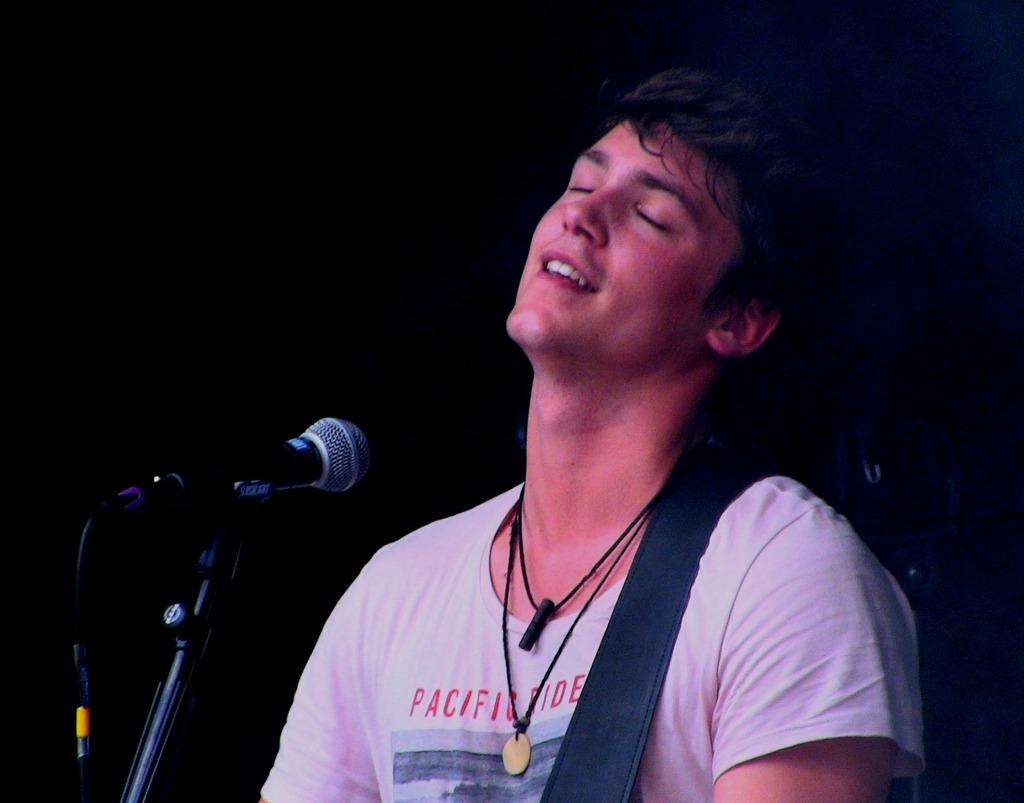What is the main subject of the image? The main subject of the image is a man. What is the man doing in the image? The man is standing near a mic. Is there any equipment associated with the mic? Yes, there is a stand associated with the mic. What type of wood is the guitar made of in the image? There is no guitar present in the image, so it is not possible to determine the type of wood it might be made of. 